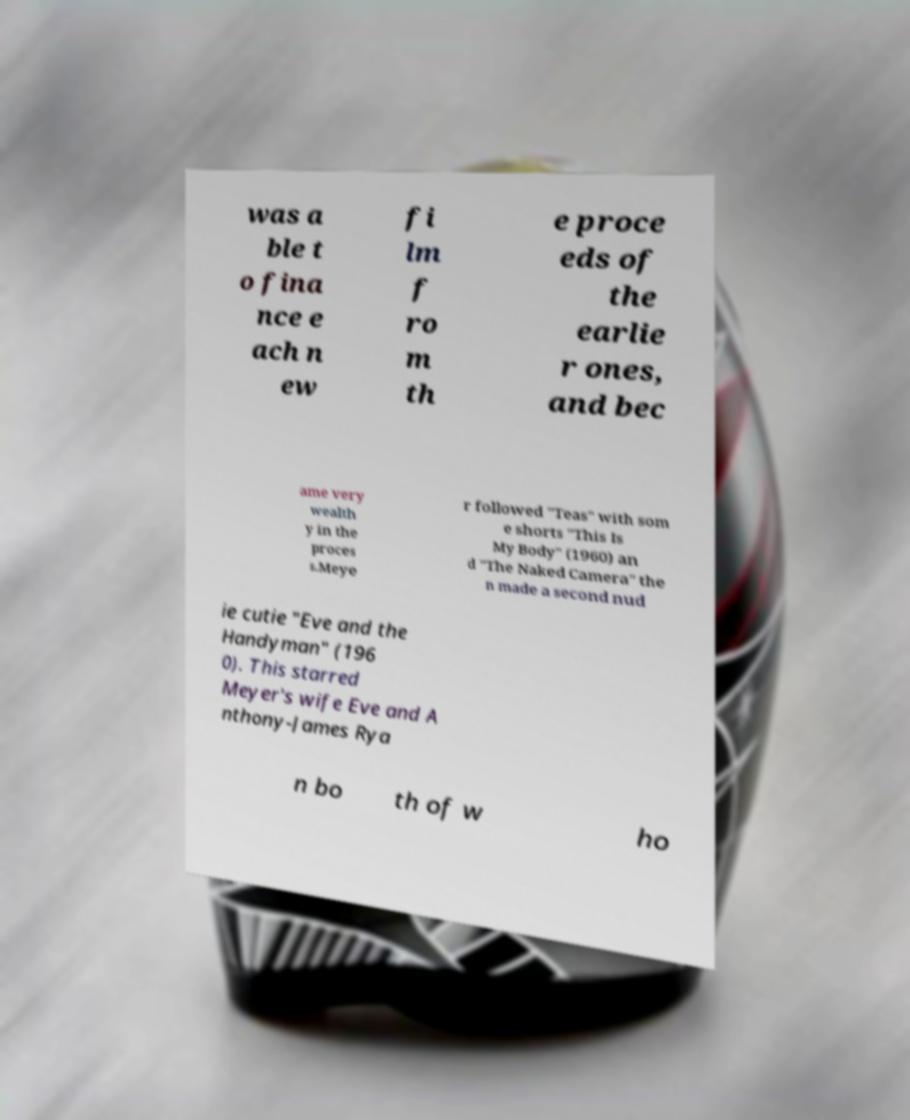Please identify and transcribe the text found in this image. was a ble t o fina nce e ach n ew fi lm f ro m th e proce eds of the earlie r ones, and bec ame very wealth y in the proces s.Meye r followed "Teas" with som e shorts "This Is My Body" (1960) an d "The Naked Camera" the n made a second nud ie cutie "Eve and the Handyman" (196 0). This starred Meyer's wife Eve and A nthony-James Rya n bo th of w ho 